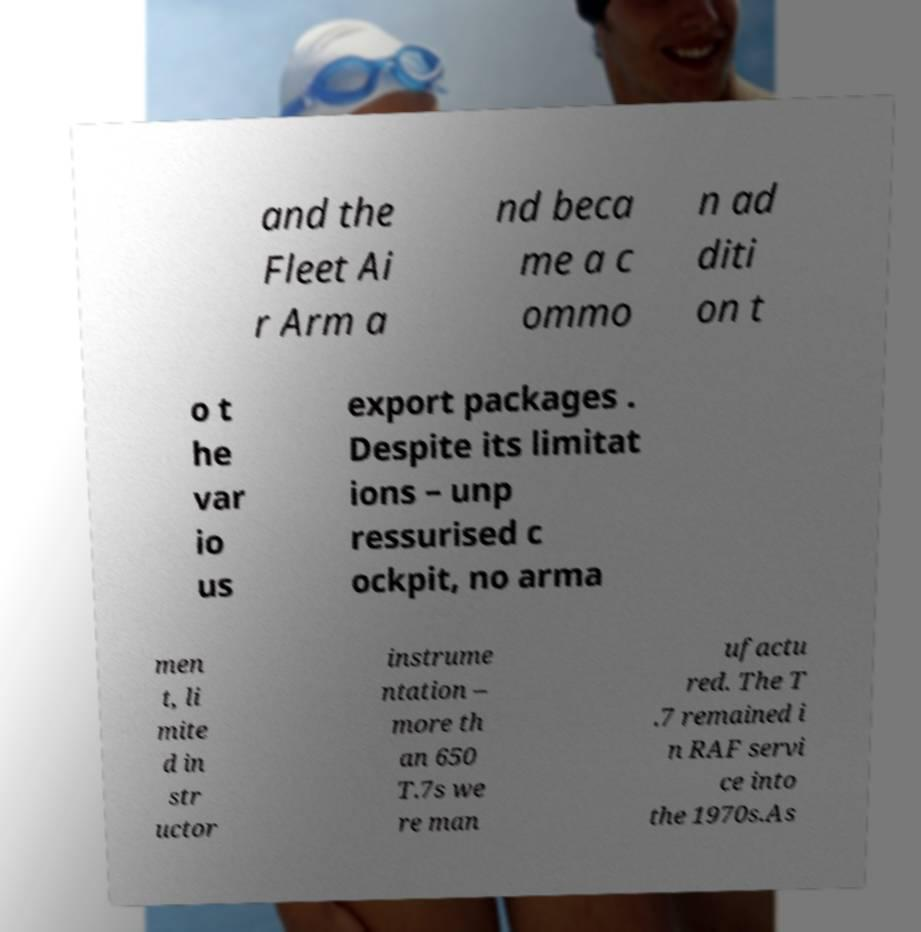For documentation purposes, I need the text within this image transcribed. Could you provide that? and the Fleet Ai r Arm a nd beca me a c ommo n ad diti on t o t he var io us export packages . Despite its limitat ions – unp ressurised c ockpit, no arma men t, li mite d in str uctor instrume ntation – more th an 650 T.7s we re man ufactu red. The T .7 remained i n RAF servi ce into the 1970s.As 